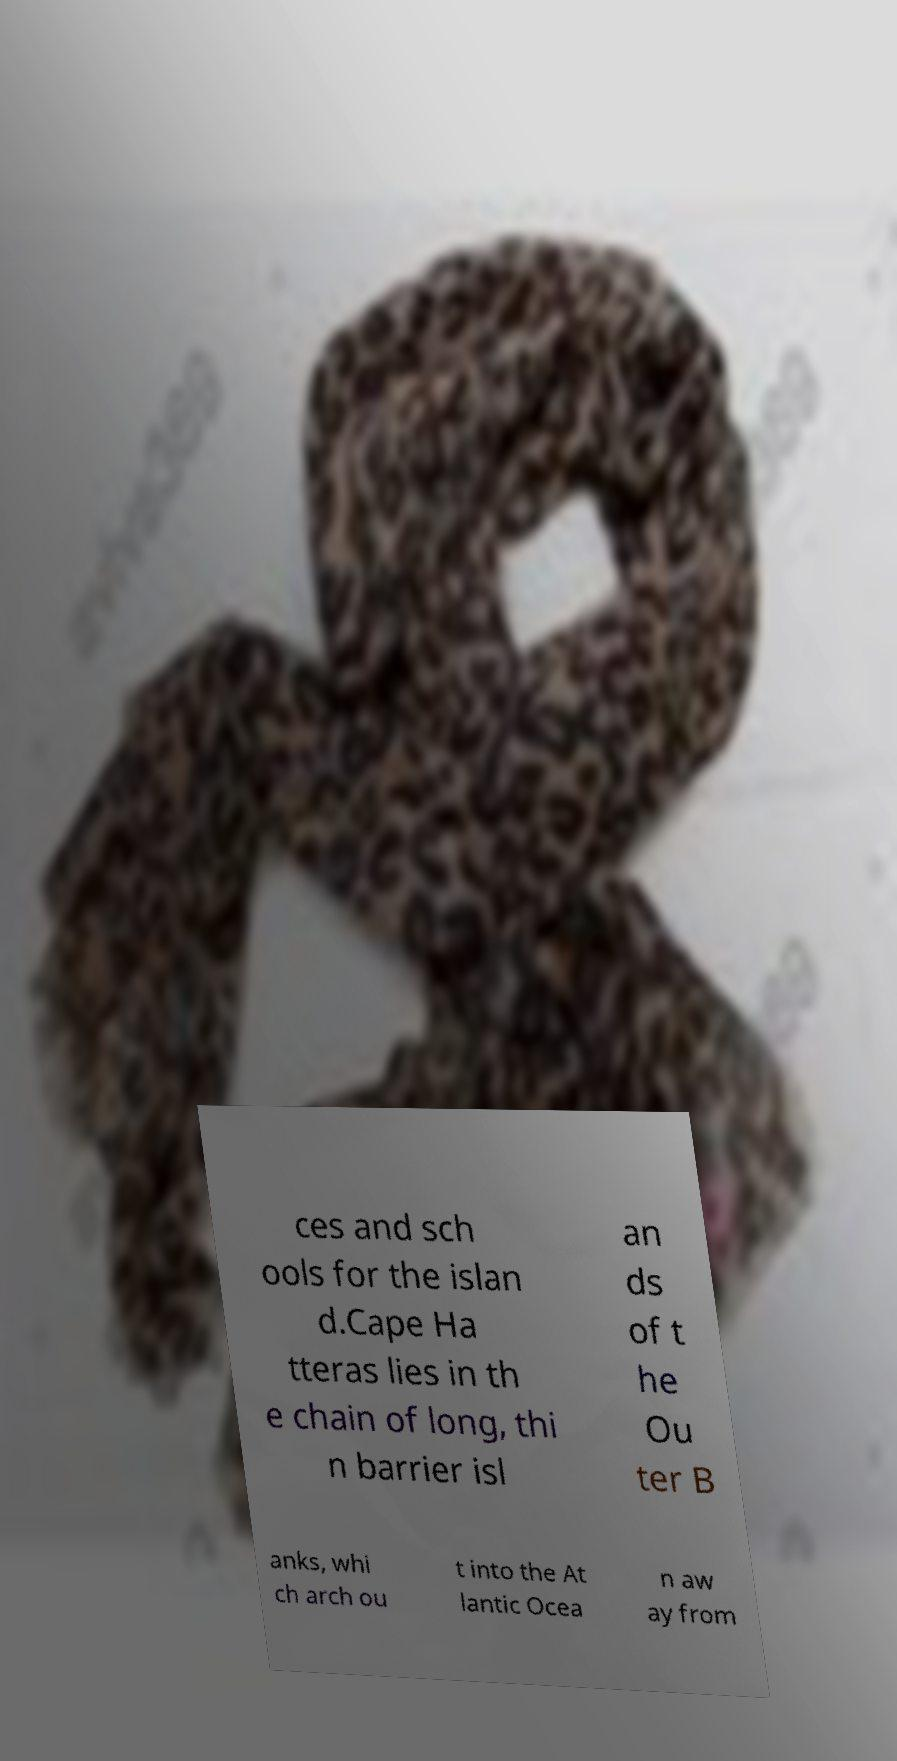Please identify and transcribe the text found in this image. ces and sch ools for the islan d.Cape Ha tteras lies in th e chain of long, thi n barrier isl an ds of t he Ou ter B anks, whi ch arch ou t into the At lantic Ocea n aw ay from 